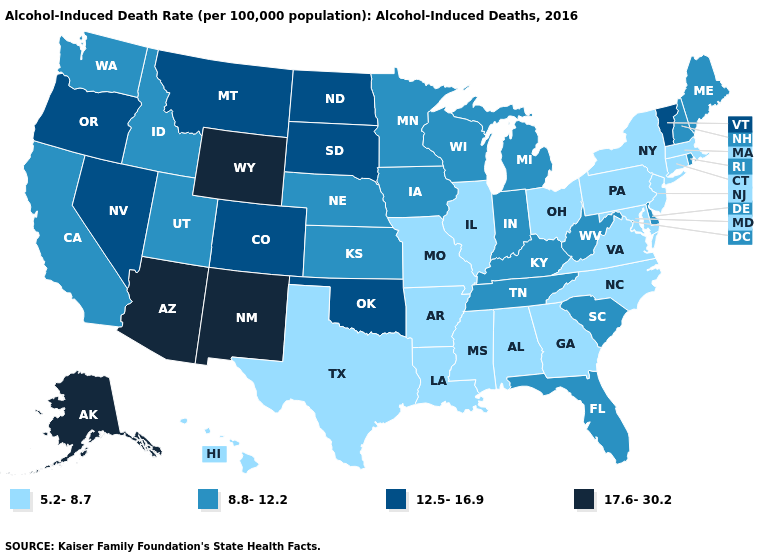Among the states that border Massachusetts , does Vermont have the lowest value?
Give a very brief answer. No. What is the value of Arkansas?
Keep it brief. 5.2-8.7. Which states have the highest value in the USA?
Write a very short answer. Alaska, Arizona, New Mexico, Wyoming. Among the states that border North Carolina , does Virginia have the highest value?
Keep it brief. No. Which states have the highest value in the USA?
Concise answer only. Alaska, Arizona, New Mexico, Wyoming. Does Washington have the same value as Maine?
Quick response, please. Yes. What is the highest value in the USA?
Keep it brief. 17.6-30.2. Does Mississippi have the highest value in the South?
Short answer required. No. How many symbols are there in the legend?
Keep it brief. 4. Among the states that border Colorado , does Utah have the lowest value?
Be succinct. Yes. What is the value of Oregon?
Be succinct. 12.5-16.9. What is the value of New York?
Concise answer only. 5.2-8.7. Name the states that have a value in the range 8.8-12.2?
Be succinct. California, Delaware, Florida, Idaho, Indiana, Iowa, Kansas, Kentucky, Maine, Michigan, Minnesota, Nebraska, New Hampshire, Rhode Island, South Carolina, Tennessee, Utah, Washington, West Virginia, Wisconsin. What is the value of South Dakota?
Be succinct. 12.5-16.9. 